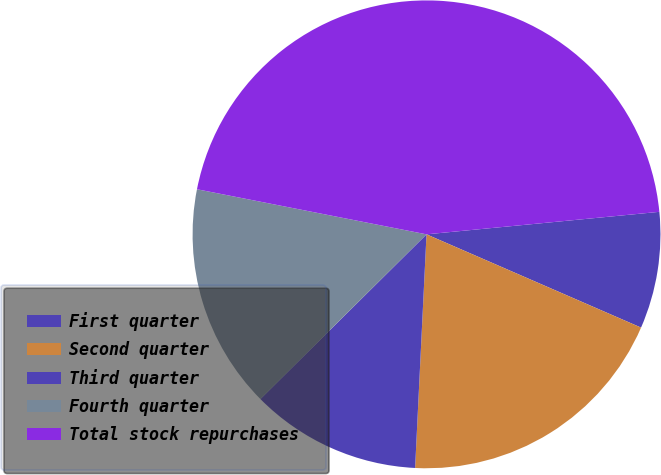<chart> <loc_0><loc_0><loc_500><loc_500><pie_chart><fcel>First quarter<fcel>Second quarter<fcel>Third quarter<fcel>Fourth quarter<fcel>Total stock repurchases<nl><fcel>8.06%<fcel>19.25%<fcel>11.79%<fcel>15.52%<fcel>45.38%<nl></chart> 